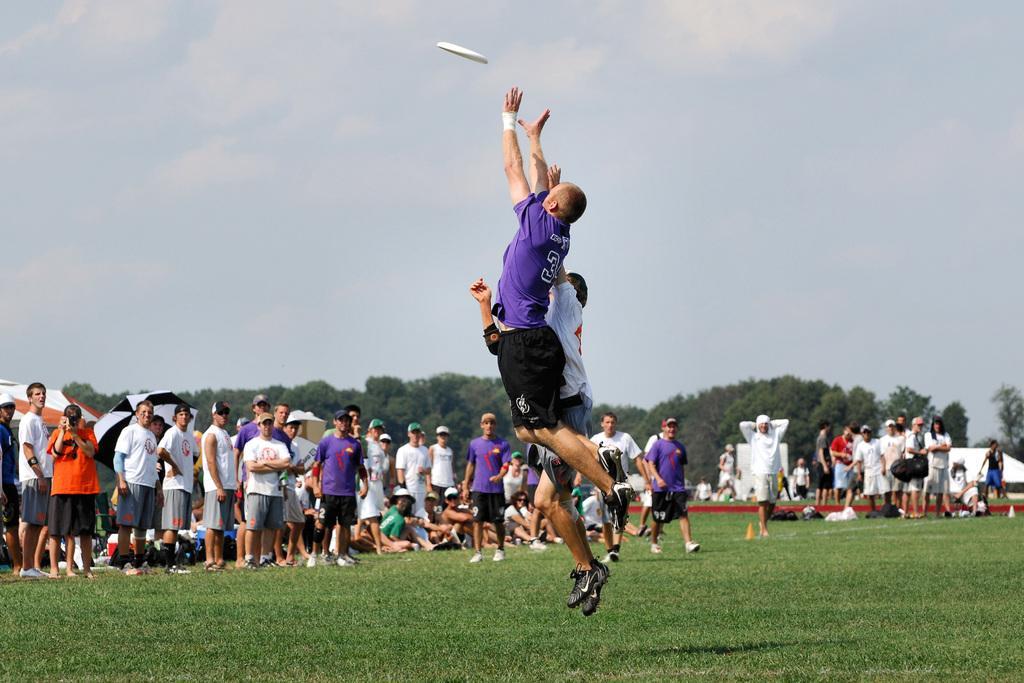Please provide a concise description of this image. In this image we can see two people are playing sports with one object. And surrounding people are watching them and one person is holding the camera. And bottom we can see grass. And in background we can see some trees and clouds in the sky. 